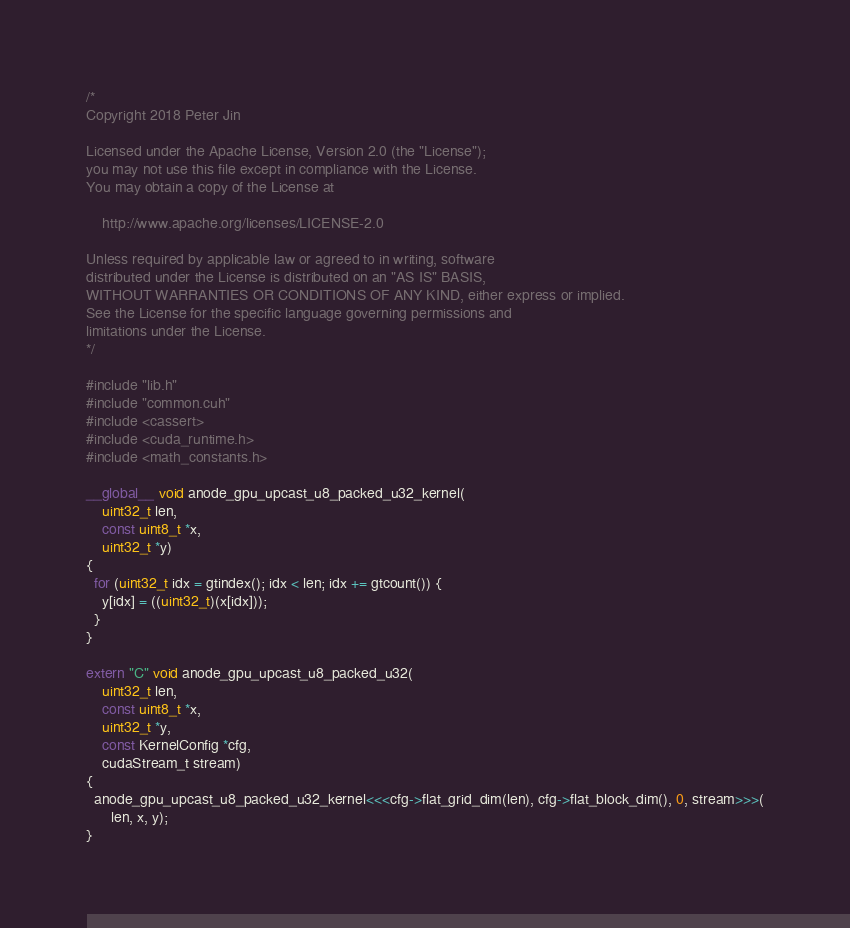Convert code to text. <code><loc_0><loc_0><loc_500><loc_500><_Cuda_>/*
Copyright 2018 Peter Jin

Licensed under the Apache License, Version 2.0 (the "License");
you may not use this file except in compliance with the License.
You may obtain a copy of the License at

    http://www.apache.org/licenses/LICENSE-2.0

Unless required by applicable law or agreed to in writing, software
distributed under the License is distributed on an "AS IS" BASIS,
WITHOUT WARRANTIES OR CONDITIONS OF ANY KIND, either express or implied.
See the License for the specific language governing permissions and
limitations under the License.
*/

#include "lib.h"
#include "common.cuh"
#include <cassert>
#include <cuda_runtime.h>
#include <math_constants.h>

__global__ void anode_gpu_upcast_u8_packed_u32_kernel(
    uint32_t len,
    const uint8_t *x,
    uint32_t *y)
{
  for (uint32_t idx = gtindex(); idx < len; idx += gtcount()) {
    y[idx] = ((uint32_t)(x[idx]));
  }
}

extern "C" void anode_gpu_upcast_u8_packed_u32(
    uint32_t len,
    const uint8_t *x,
    uint32_t *y,
    const KernelConfig *cfg,
    cudaStream_t stream)
{
  anode_gpu_upcast_u8_packed_u32_kernel<<<cfg->flat_grid_dim(len), cfg->flat_block_dim(), 0, stream>>>(
      len, x, y);
}
</code> 